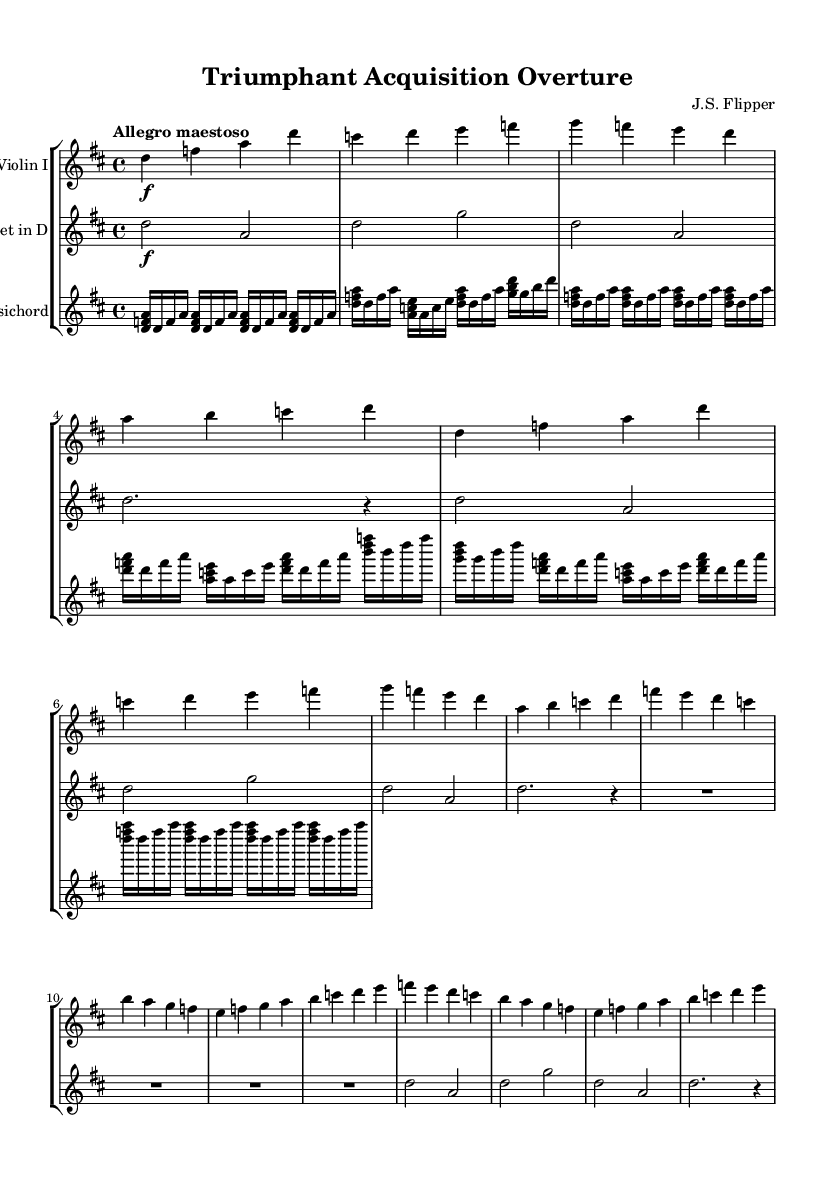What is the key signature of this music? The key signature indicates that this piece is in D major, which has two sharps (F# and C#). This can be identified from the key at the beginning of the music.
Answer: D major What is the time signature of this music? The time signature is 4/4, meaning there are four beats in each measure, which can be observed at the beginning of the score.
Answer: 4/4 What is the tempo marking for this piece? The tempo marking is "Allegro maestoso," which suggests a fast and majestic pace. This is clearly indicated at the start of the music.
Answer: Allegro maestoso How many main themes are present in this overture? There are two main themes presented as Main Theme A and Main Theme B, which can be identified in the structure of the music sections.
Answer: 2 Which instruments are featured in this piece? The instruments mentioned in the score are Violin I, Trumpet in D, and Harpsichord, each clearly labeled in their respective staff sections.
Answer: Violin I, Trumpet in D, Harpsichord What is the dynamic marking at the beginning of the introduction? The dynamic marking at the beginning is forte (f), which indicates that the section should be played loudly. This can be seen notated in the music for that initial part.
Answer: forte 